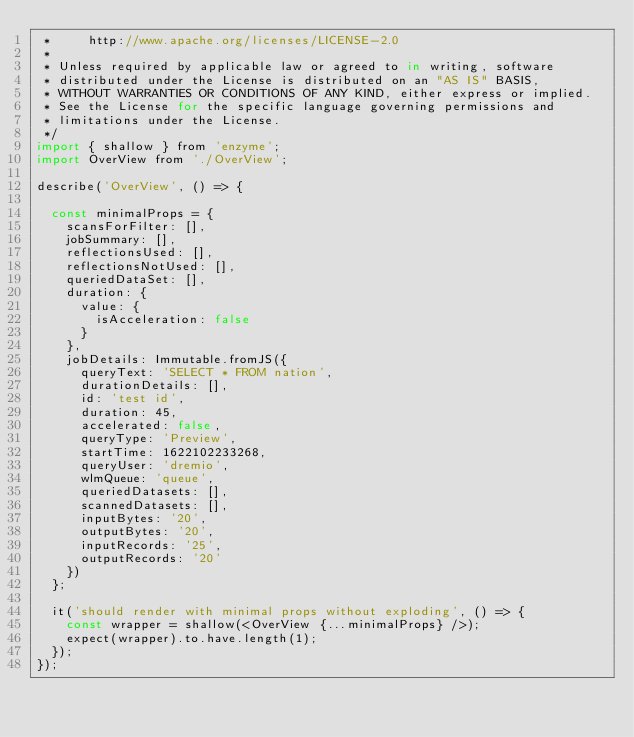Convert code to text. <code><loc_0><loc_0><loc_500><loc_500><_JavaScript_> *     http://www.apache.org/licenses/LICENSE-2.0
 *
 * Unless required by applicable law or agreed to in writing, software
 * distributed under the License is distributed on an "AS IS" BASIS,
 * WITHOUT WARRANTIES OR CONDITIONS OF ANY KIND, either express or implied.
 * See the License for the specific language governing permissions and
 * limitations under the License.
 */
import { shallow } from 'enzyme';
import OverView from './OverView';

describe('OverView', () => {

  const minimalProps = {
    scansForFilter: [],
    jobSummary: [],
    reflectionsUsed: [],
    reflectionsNotUsed: [],
    queriedDataSet: [],
    duration: {
      value: {
        isAcceleration: false
      }
    },
    jobDetails: Immutable.fromJS({
      queryText: 'SELECT * FROM nation',
      durationDetails: [],
      id: 'test id',
      duration: 45,
      accelerated: false,
      queryType: 'Preview',
      startTime: 1622102233268,
      queryUser: 'dremio',
      wlmQueue: 'queue',
      queriedDatasets: [],
      scannedDatasets: [],
      inputBytes: '20',
      outputBytes: '20',
      inputRecords: '25',
      outputRecords: '20'
    })
  };

  it('should render with minimal props without exploding', () => {
    const wrapper = shallow(<OverView {...minimalProps} />);
    expect(wrapper).to.have.length(1);
  });
});
</code> 